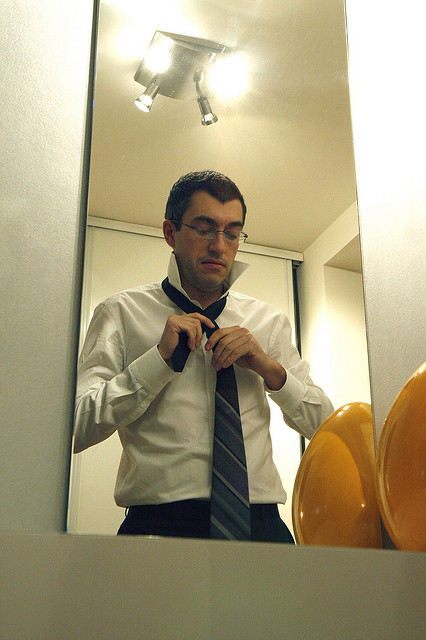Can you describe the man’s facial expression? The man appears to be focused and mildly concentrated as he adjusts his necktie in front of the mirror. His expression indicates that he is carefully ensuring his appearance is just right, reflecting a moment of personal grooming. Does the image suggest any particular time of day? The image does not provide clear indications of the time of day. However, the presence of artificial lighting and the indoor setting suggest it could be either morning or evening, times typically associated with preparing for the day ahead or an event in the evening. 